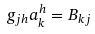Convert formula to latex. <formula><loc_0><loc_0><loc_500><loc_500>g _ { j h } a _ { k } ^ { h } = B _ { k j }</formula> 